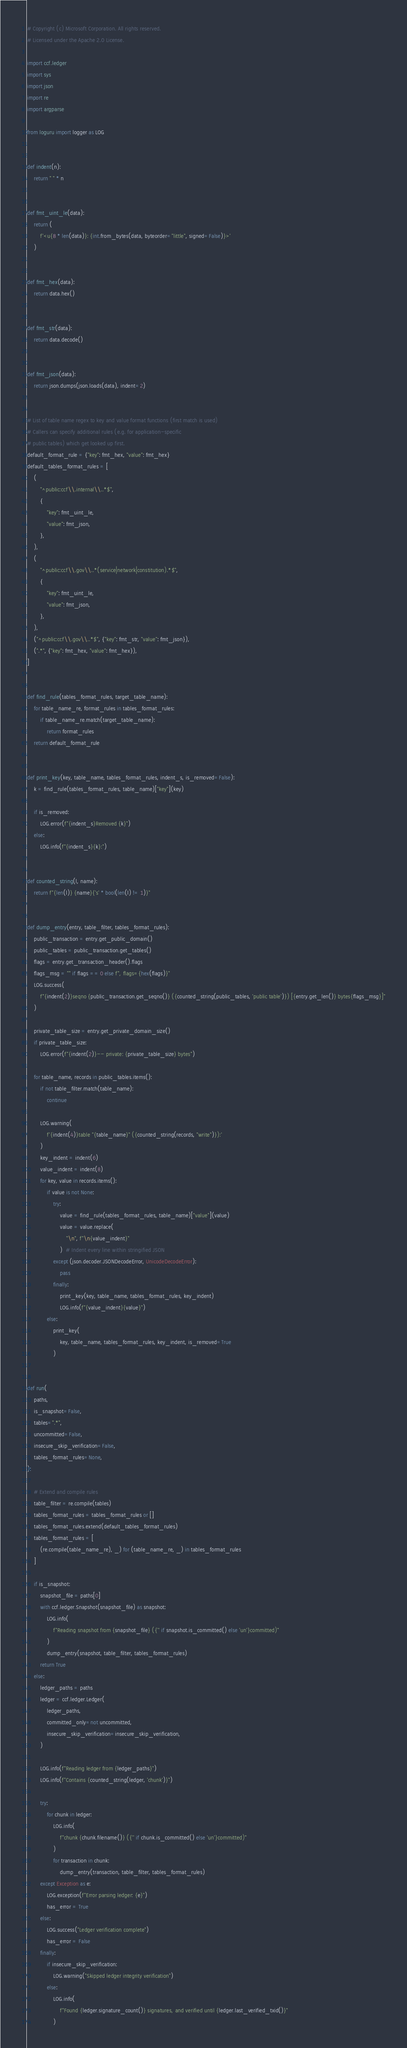Convert code to text. <code><loc_0><loc_0><loc_500><loc_500><_Python_># Copyright (c) Microsoft Corporation. All rights reserved.
# Licensed under the Apache 2.0 License.

import ccf.ledger
import sys
import json
import re
import argparse

from loguru import logger as LOG


def indent(n):
    return " " * n


def fmt_uint_le(data):
    return (
        f'<u{8 * len(data)}: {int.from_bytes(data, byteorder="little", signed=False)}>'
    )


def fmt_hex(data):
    return data.hex()


def fmt_str(data):
    return data.decode()


def fmt_json(data):
    return json.dumps(json.loads(data), indent=2)


# List of table name regex to key and value format functions (first match is used)
# Callers can specify additional rules (e.g. for application-specific
# public tables) which get looked up first.
default_format_rule = {"key": fmt_hex, "value": fmt_hex}
default_tables_format_rules = [
    (
        "^public:ccf\\.internal\\..*$",
        {
            "key": fmt_uint_le,
            "value": fmt_json,
        },
    ),
    (
        "^public:ccf\\.gov\\..*(service|network|constitution).*$",
        {
            "key": fmt_uint_le,
            "value": fmt_json,
        },
    ),
    ("^public:ccf\\.gov\\..*$", {"key": fmt_str, "value": fmt_json}),
    (".*", {"key": fmt_hex, "value": fmt_hex}),
]


def find_rule(tables_format_rules, target_table_name):
    for table_name_re, format_rules in tables_format_rules:
        if table_name_re.match(target_table_name):
            return format_rules
    return default_format_rule


def print_key(key, table_name, tables_format_rules, indent_s, is_removed=False):
    k = find_rule(tables_format_rules, table_name)["key"](key)

    if is_removed:
        LOG.error(f"{indent_s}Removed {k}")
    else:
        LOG.info(f"{indent_s}{k}:")


def counted_string(l, name):
    return f"{len(l)} {name}{'s' * bool(len(l) != 1)}"


def dump_entry(entry, table_filter, tables_format_rules):
    public_transaction = entry.get_public_domain()
    public_tables = public_transaction.get_tables()
    flags = entry.get_transaction_header().flags
    flags_msg = "" if flags == 0 else f", flags={hex(flags)}"
    LOG.success(
        f"{indent(2)}seqno {public_transaction.get_seqno()} ({counted_string(public_tables, 'public table')}) [{entry.get_len()} bytes{flags_msg}]"
    )

    private_table_size = entry.get_private_domain_size()
    if private_table_size:
        LOG.error(f"{indent(2)}-- private: {private_table_size} bytes")

    for table_name, records in public_tables.items():
        if not table_filter.match(table_name):
            continue

        LOG.warning(
            f'{indent(4)}table "{table_name}" ({counted_string(records, "write")}):'
        )
        key_indent = indent(6)
        value_indent = indent(8)
        for key, value in records.items():
            if value is not None:
                try:
                    value = find_rule(tables_format_rules, table_name)["value"](value)
                    value = value.replace(
                        "\n", f"\n{value_indent}"
                    )  # Indent every line within stringified JSON
                except (json.decoder.JSONDecodeError, UnicodeDecodeError):
                    pass
                finally:
                    print_key(key, table_name, tables_format_rules, key_indent)
                    LOG.info(f"{value_indent}{value}")
            else:
                print_key(
                    key, table_name, tables_format_rules, key_indent, is_removed=True
                )


def run(
    paths,
    is_snapshot=False,
    tables=".*",
    uncommitted=False,
    insecure_skip_verification=False,
    tables_format_rules=None,
):

    # Extend and compile rules
    table_filter = re.compile(tables)
    tables_format_rules = tables_format_rules or []
    tables_format_rules.extend(default_tables_format_rules)
    tables_format_rules = [
        (re.compile(table_name_re), _) for (table_name_re, _) in tables_format_rules
    ]

    if is_snapshot:
        snapshot_file = paths[0]
        with ccf.ledger.Snapshot(snapshot_file) as snapshot:
            LOG.info(
                f"Reading snapshot from {snapshot_file} ({'' if snapshot.is_committed() else 'un'}committed)"
            )
            dump_entry(snapshot, table_filter, tables_format_rules)
        return True
    else:
        ledger_paths = paths
        ledger = ccf.ledger.Ledger(
            ledger_paths,
            committed_only=not uncommitted,
            insecure_skip_verification=insecure_skip_verification,
        )

        LOG.info(f"Reading ledger from {ledger_paths}")
        LOG.info(f"Contains {counted_string(ledger, 'chunk')}")

        try:
            for chunk in ledger:
                LOG.info(
                    f"chunk {chunk.filename()} ({'' if chunk.is_committed() else 'un'}committed)"
                )
                for transaction in chunk:
                    dump_entry(transaction, table_filter, tables_format_rules)
        except Exception as e:
            LOG.exception(f"Error parsing ledger: {e}")
            has_error = True
        else:
            LOG.success("Ledger verification complete")
            has_error = False
        finally:
            if insecure_skip_verification:
                LOG.warning("Skipped ledger integrity verification")
            else:
                LOG.info(
                    f"Found {ledger.signature_count()} signatures, and verified until {ledger.last_verified_txid()}"
                )</code> 